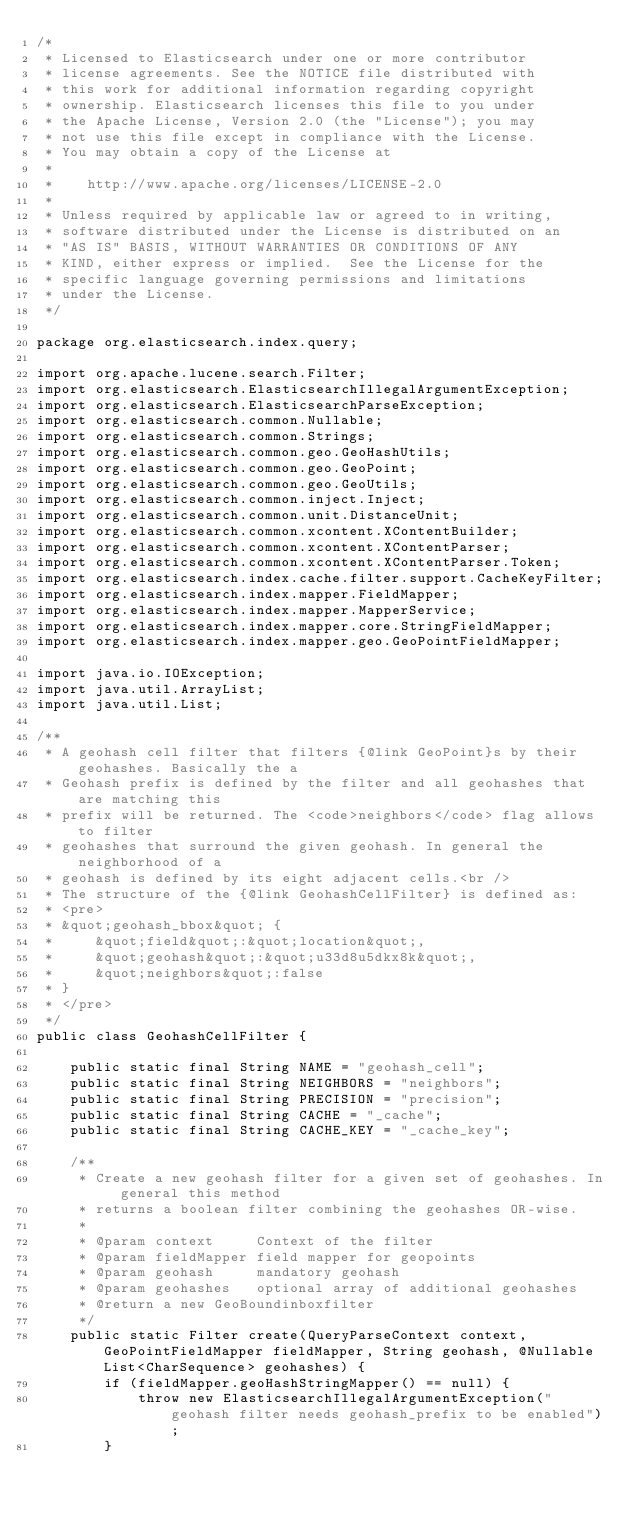Convert code to text. <code><loc_0><loc_0><loc_500><loc_500><_Java_>/*
 * Licensed to Elasticsearch under one or more contributor
 * license agreements. See the NOTICE file distributed with
 * this work for additional information regarding copyright
 * ownership. Elasticsearch licenses this file to you under
 * the Apache License, Version 2.0 (the "License"); you may
 * not use this file except in compliance with the License.
 * You may obtain a copy of the License at
 *
 *    http://www.apache.org/licenses/LICENSE-2.0
 *
 * Unless required by applicable law or agreed to in writing,
 * software distributed under the License is distributed on an
 * "AS IS" BASIS, WITHOUT WARRANTIES OR CONDITIONS OF ANY
 * KIND, either express or implied.  See the License for the
 * specific language governing permissions and limitations
 * under the License.
 */

package org.elasticsearch.index.query;

import org.apache.lucene.search.Filter;
import org.elasticsearch.ElasticsearchIllegalArgumentException;
import org.elasticsearch.ElasticsearchParseException;
import org.elasticsearch.common.Nullable;
import org.elasticsearch.common.Strings;
import org.elasticsearch.common.geo.GeoHashUtils;
import org.elasticsearch.common.geo.GeoPoint;
import org.elasticsearch.common.geo.GeoUtils;
import org.elasticsearch.common.inject.Inject;
import org.elasticsearch.common.unit.DistanceUnit;
import org.elasticsearch.common.xcontent.XContentBuilder;
import org.elasticsearch.common.xcontent.XContentParser;
import org.elasticsearch.common.xcontent.XContentParser.Token;
import org.elasticsearch.index.cache.filter.support.CacheKeyFilter;
import org.elasticsearch.index.mapper.FieldMapper;
import org.elasticsearch.index.mapper.MapperService;
import org.elasticsearch.index.mapper.core.StringFieldMapper;
import org.elasticsearch.index.mapper.geo.GeoPointFieldMapper;

import java.io.IOException;
import java.util.ArrayList;
import java.util.List;

/**
 * A geohash cell filter that filters {@link GeoPoint}s by their geohashes. Basically the a
 * Geohash prefix is defined by the filter and all geohashes that are matching this
 * prefix will be returned. The <code>neighbors</code> flag allows to filter
 * geohashes that surround the given geohash. In general the neighborhood of a
 * geohash is defined by its eight adjacent cells.<br />
 * The structure of the {@link GeohashCellFilter} is defined as:
 * <pre>
 * &quot;geohash_bbox&quot; {
 *     &quot;field&quot;:&quot;location&quot;,
 *     &quot;geohash&quot;:&quot;u33d8u5dkx8k&quot;,
 *     &quot;neighbors&quot;:false
 * }
 * </pre>
 */
public class GeohashCellFilter {

    public static final String NAME = "geohash_cell";
    public static final String NEIGHBORS = "neighbors";
    public static final String PRECISION = "precision";
    public static final String CACHE = "_cache";
    public static final String CACHE_KEY = "_cache_key";

    /**
     * Create a new geohash filter for a given set of geohashes. In general this method
     * returns a boolean filter combining the geohashes OR-wise.
     *
     * @param context     Context of the filter
     * @param fieldMapper field mapper for geopoints
     * @param geohash     mandatory geohash
     * @param geohashes   optional array of additional geohashes
     * @return a new GeoBoundinboxfilter
     */
    public static Filter create(QueryParseContext context, GeoPointFieldMapper fieldMapper, String geohash, @Nullable List<CharSequence> geohashes) {
        if (fieldMapper.geoHashStringMapper() == null) {
            throw new ElasticsearchIllegalArgumentException("geohash filter needs geohash_prefix to be enabled");
        }
</code> 